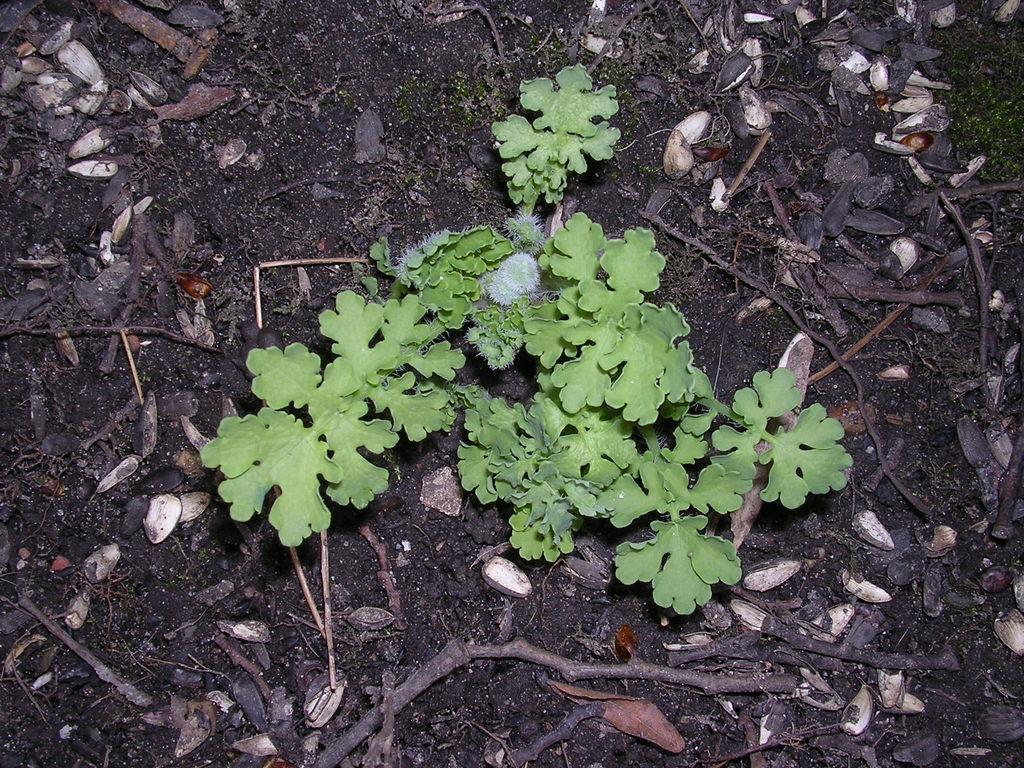What type of vegetation is present in the image? There are green-colored leaves in the image. What else can be seen on the ground in the image? There are sticks on the ground in the image. Where is the mark located in the image? There is no mark present in the image. What type of playground equipment can be seen in the image? There is no playground equipment present in the image. 